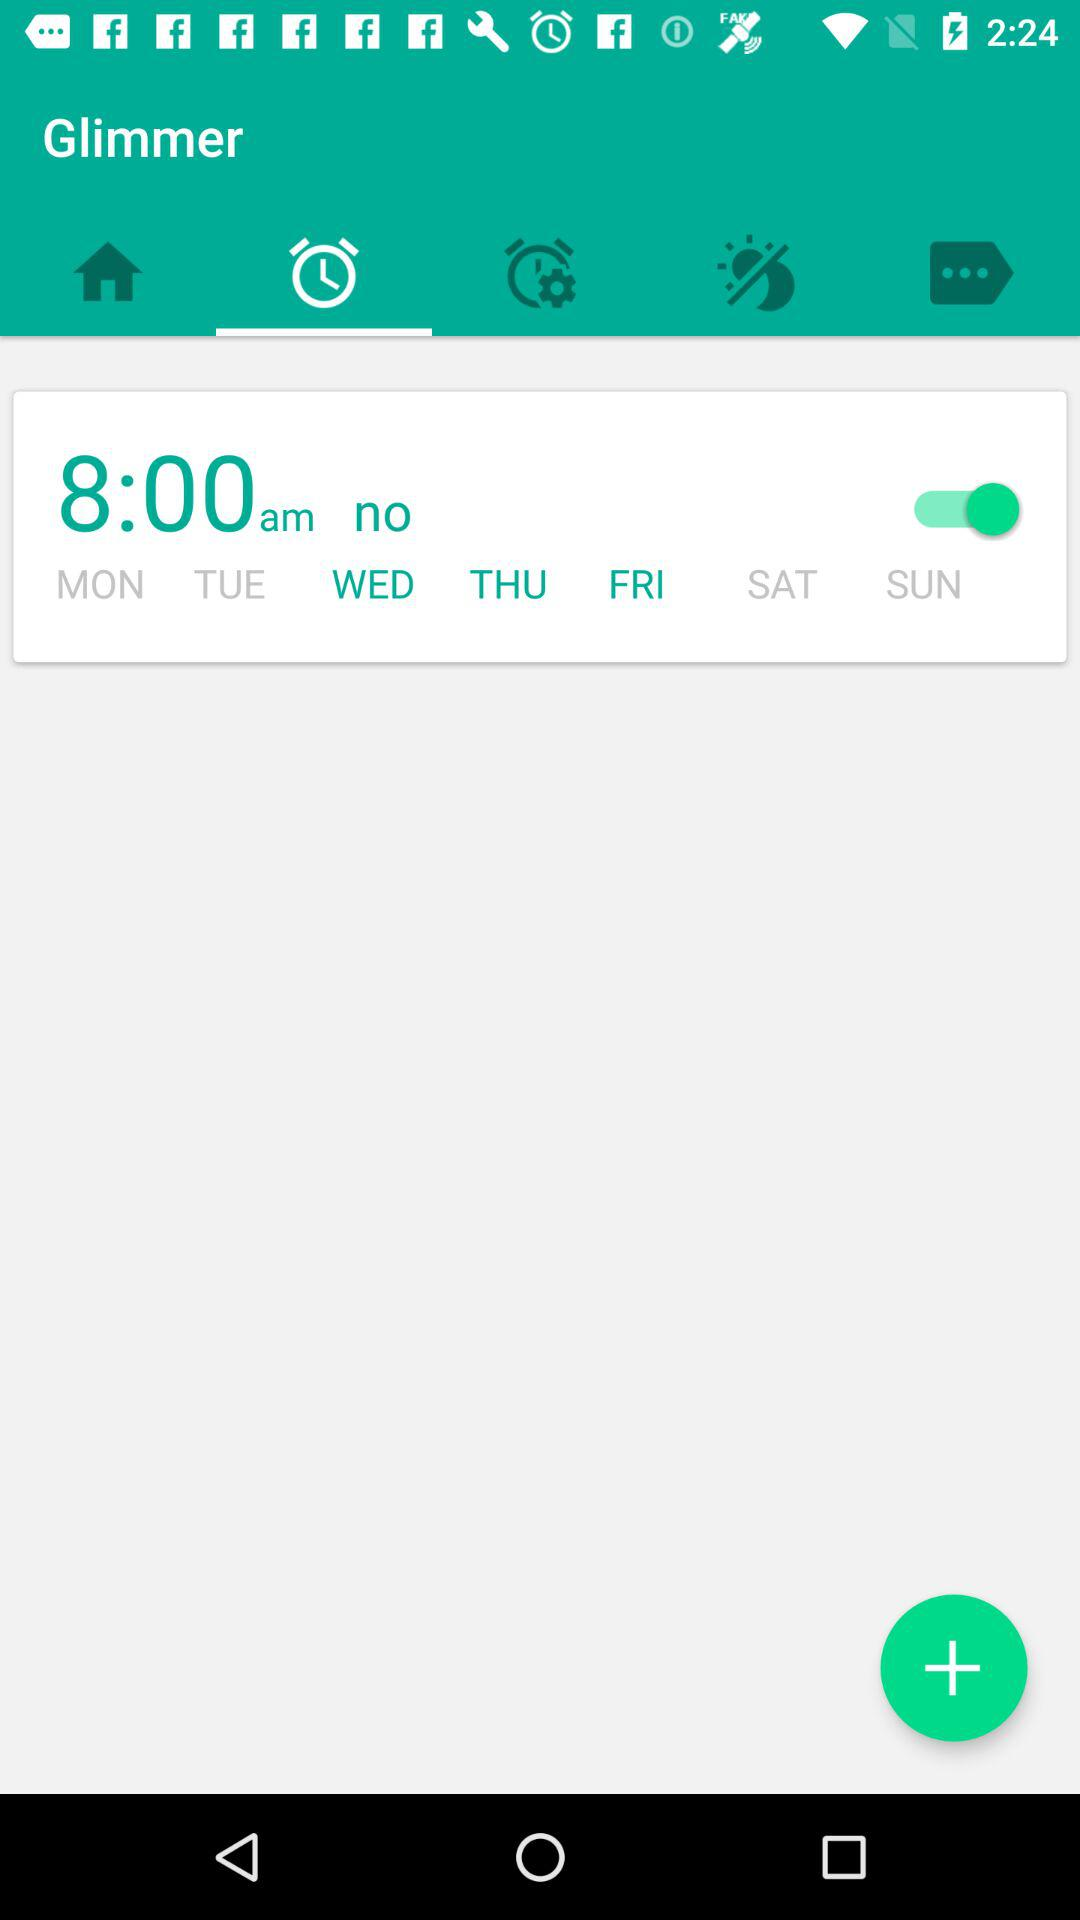What is the set time for the alarm? The set time for the alarm is 8:00 a.m. 